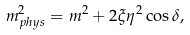Convert formula to latex. <formula><loc_0><loc_0><loc_500><loc_500>m ^ { 2 } _ { p h y s } = m ^ { 2 } + 2 \xi \eta ^ { 2 } \cos \delta ,</formula> 